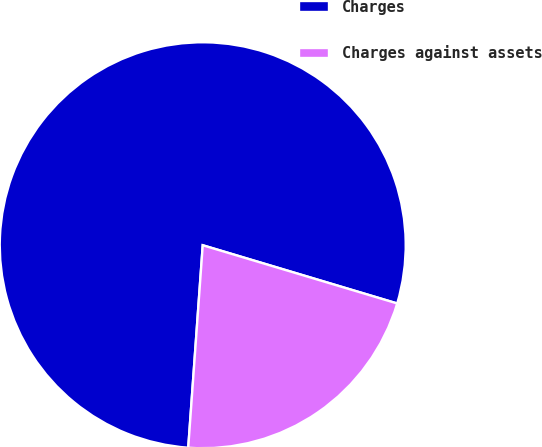Convert chart. <chart><loc_0><loc_0><loc_500><loc_500><pie_chart><fcel>Charges<fcel>Charges against assets<nl><fcel>78.49%<fcel>21.51%<nl></chart> 